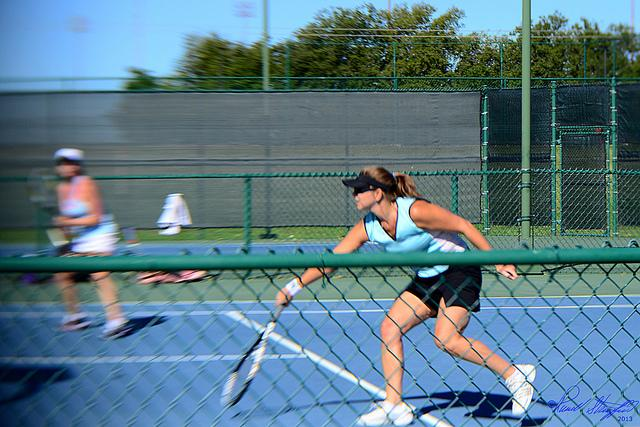What surface are they playing on? tennis court 